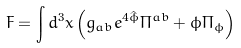<formula> <loc_0><loc_0><loc_500><loc_500>F = \int d ^ { 3 } x \left ( g _ { a b } e ^ { 4 \hat { \phi } } \Pi ^ { a b } + \phi \Pi _ { \phi } \right )</formula> 